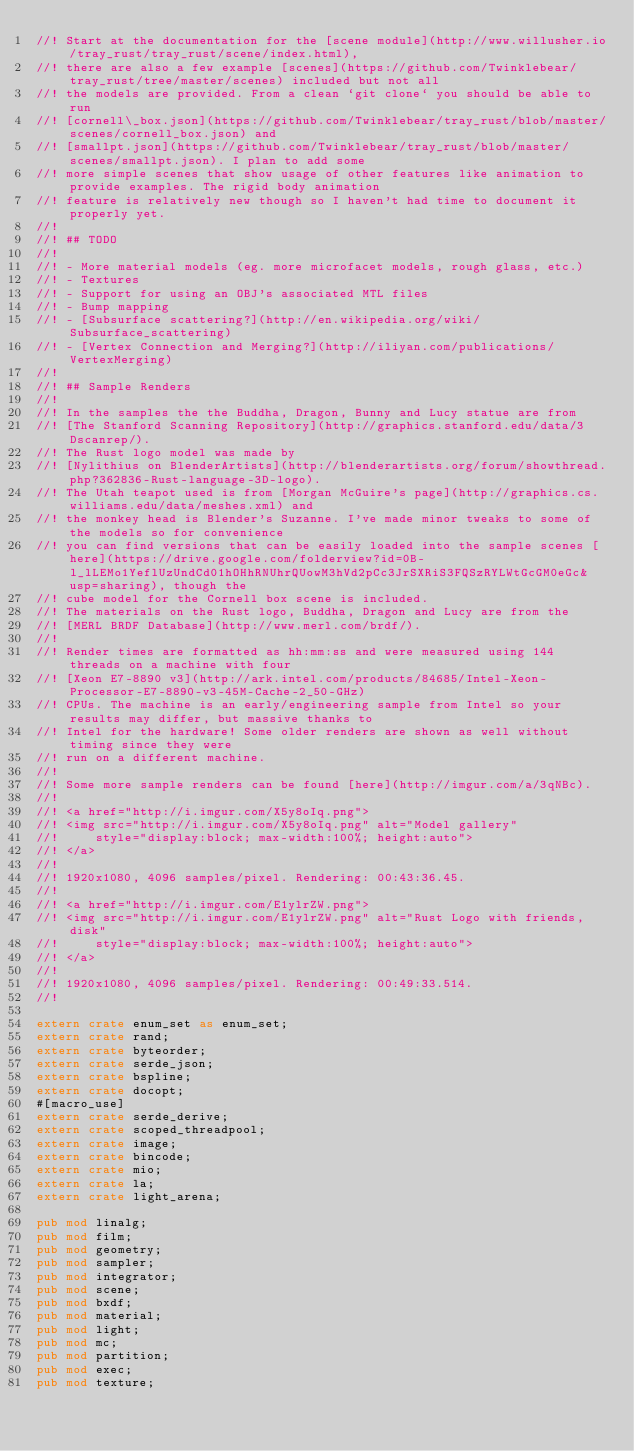Convert code to text. <code><loc_0><loc_0><loc_500><loc_500><_Rust_>//! Start at the documentation for the [scene module](http://www.willusher.io/tray_rust/tray_rust/scene/index.html),
//! there are also a few example [scenes](https://github.com/Twinklebear/tray_rust/tree/master/scenes) included but not all
//! the models are provided. From a clean `git clone` you should be able to run
//! [cornell\_box.json](https://github.com/Twinklebear/tray_rust/blob/master/scenes/cornell_box.json) and
//! [smallpt.json](https://github.com/Twinklebear/tray_rust/blob/master/scenes/smallpt.json). I plan to add some
//! more simple scenes that show usage of other features like animation to provide examples. The rigid body animation
//! feature is relatively new though so I haven't had time to document it properly yet.
//! 
//! ## TODO
//!
//! - More material models (eg. more microfacet models, rough glass, etc.)
//! - Textures
//! - Support for using an OBJ's associated MTL files
//! - Bump mapping
//! - [Subsurface scattering?](http://en.wikipedia.org/wiki/Subsurface_scattering)
//! - [Vertex Connection and Merging?](http://iliyan.com/publications/VertexMerging)
//! 
//! ## Sample Renders
//!
//! In the samples the the Buddha, Dragon, Bunny and Lucy statue are from
//! [The Stanford Scanning Repository](http://graphics.stanford.edu/data/3Dscanrep/).
//! The Rust logo model was made by
//! [Nylithius on BlenderArtists](http://blenderartists.org/forum/showthread.php?362836-Rust-language-3D-logo).
//! The Utah teapot used is from [Morgan McGuire's page](http://graphics.cs.williams.edu/data/meshes.xml) and
//! the monkey head is Blender's Suzanne. I've made minor tweaks to some of the models so for convenience
//! you can find versions that can be easily loaded into the sample scenes [here](https://drive.google.com/folderview?id=0B-l_lLEMo1YeflUzUndCd01hOHhRNUhrQUowM3hVd2pCc3JrSXRiS3FQSzRYLWtGcGM0eGc&usp=sharing), though the
//! cube model for the Cornell box scene is included.
//! The materials on the Rust logo, Buddha, Dragon and Lucy are from the
//! [MERL BRDF Database](http://www.merl.com/brdf/).
//!
//! Render times are formatted as hh:mm:ss and were measured using 144 threads on a machine with four
//! [Xeon E7-8890 v3](http://ark.intel.com/products/84685/Intel-Xeon-Processor-E7-8890-v3-45M-Cache-2_50-GHz)
//! CPUs. The machine is an early/engineering sample from Intel so your results may differ, but massive thanks to
//! Intel for the hardware! Some older renders are shown as well without timing since they were
//! run on a different machine.
//!
//! Some more sample renders can be found [here](http://imgur.com/a/3qNBc).
//!
//! <a href="http://i.imgur.com/X5y8oIq.png">
//! <img src="http://i.imgur.com/X5y8oIq.png" alt="Model gallery"
//!     style="display:block; max-width:100%; height:auto">
//! </a>
//! 
//! 1920x1080, 4096 samples/pixel. Rendering: 00:43:36.45.
//! 
//! <a href="http://i.imgur.com/E1ylrZW.png">
//! <img src="http://i.imgur.com/E1ylrZW.png" alt="Rust Logo with friends, disk"
//!     style="display:block; max-width:100%; height:auto">
//! </a>
//! 
//! 1920x1080, 4096 samples/pixel. Rendering: 00:49:33.514.
//! 

extern crate enum_set as enum_set;
extern crate rand;
extern crate byteorder;
extern crate serde_json;
extern crate bspline;
extern crate docopt;
#[macro_use]
extern crate serde_derive;
extern crate scoped_threadpool;
extern crate image;
extern crate bincode;
extern crate mio;
extern crate la;
extern crate light_arena;

pub mod linalg;
pub mod film;
pub mod geometry;
pub mod sampler;
pub mod integrator;
pub mod scene;
pub mod bxdf;
pub mod material;
pub mod light;
pub mod mc;
pub mod partition;
pub mod exec;
pub mod texture;

</code> 